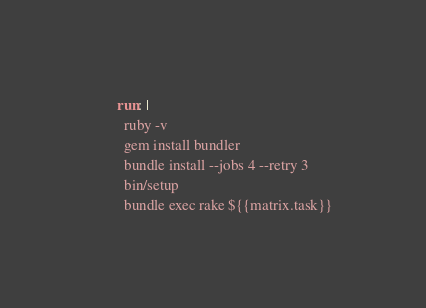<code> <loc_0><loc_0><loc_500><loc_500><_YAML_>      run: |
        ruby -v
        gem install bundler
        bundle install --jobs 4 --retry 3
        bin/setup
        bundle exec rake ${{matrix.task}}
</code> 